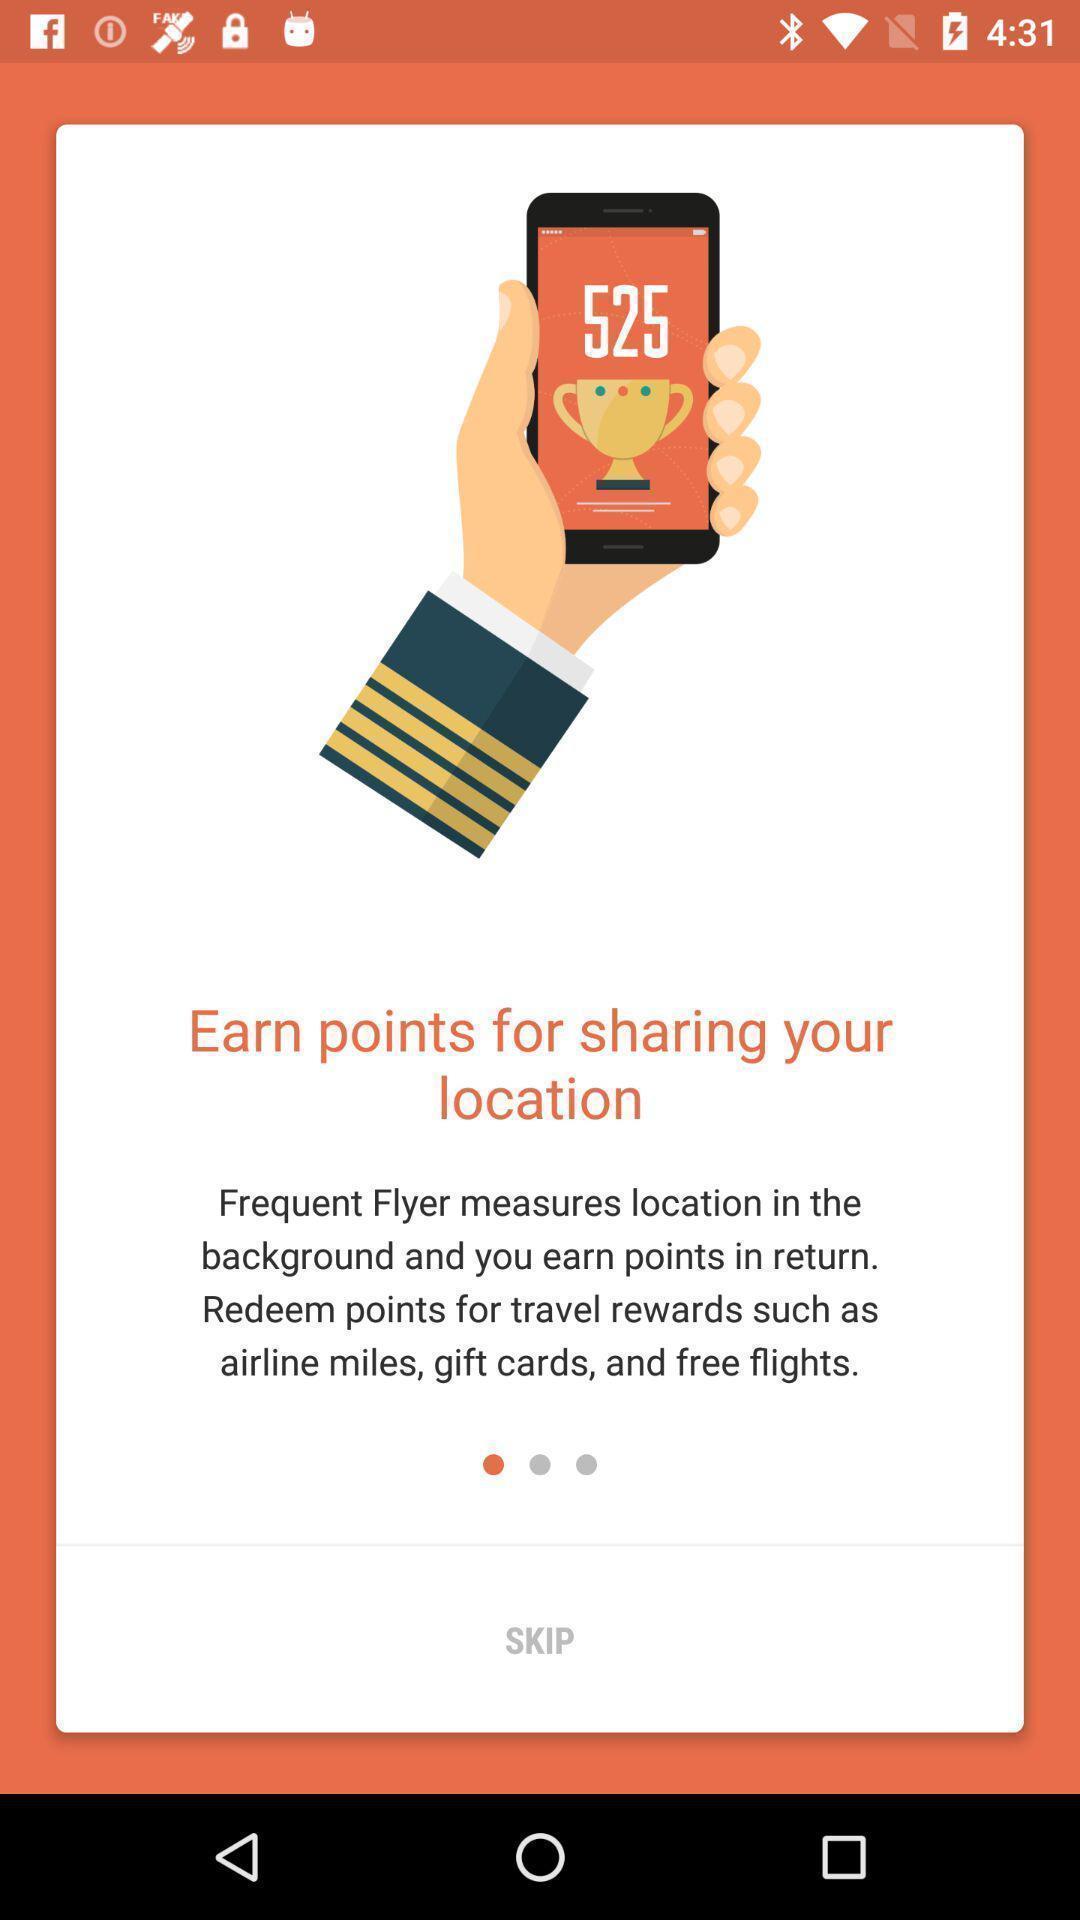Provide a detailed account of this screenshot. Welcome page displaying information about application. 